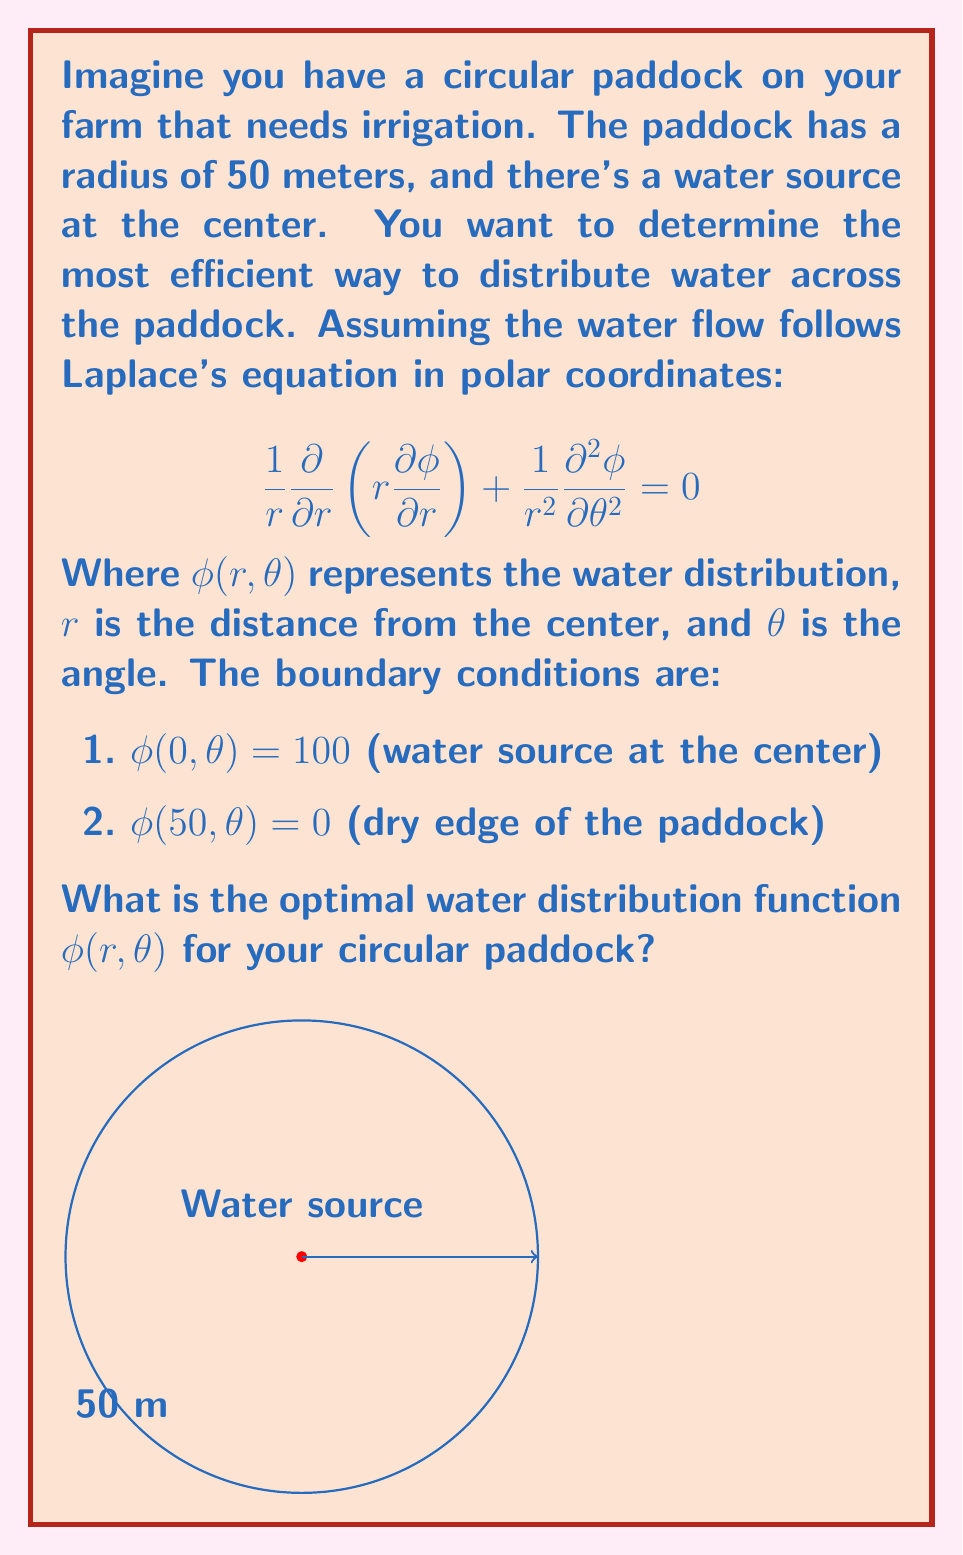Can you answer this question? Let's solve this problem step-by-step:

1) Given the circular symmetry of the problem, we can assume that the solution doesn't depend on $\theta$. This simplifies Laplace's equation to:

   $$\frac{1}{r}\frac{\partial}{\partial r}\left(r\frac{\partial \phi}{\partial r}\right) = 0$$

2) Integrating this equation once with respect to r:

   $$r\frac{\partial \phi}{\partial r} = C_1$$

3) Integrating again:

   $$\phi(r) = C_1 \ln(r) + C_2$$

4) Now we apply the boundary conditions:

   At $r = 0$: $\phi(0) = 100$
   At $r = 50$: $\phi(50) = 0$

5) Applying the second condition:

   $$0 = C_1 \ln(50) + C_2$$

6) Applying the first condition is tricky because $\ln(0)$ is undefined. Instead, we can use the fact that the solution should be finite at $r = 0$. This means $C_1$ must be zero, otherwise $\phi$ would approach infinity as $r$ approaches zero.

7) With $C_1 = 0$, we have:

   $$\phi(r) = C_2 = 100$$

8) This constant solution satisfies both boundary conditions and Laplace's equation.

Therefore, the optimal water distribution is uniform across the entire paddock, with a constant value of 100 (which represents the water level at the source).
Answer: $\phi(r,\theta) = 100$ 